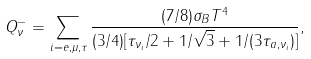<formula> <loc_0><loc_0><loc_500><loc_500>Q _ { \nu } ^ { - } = \sum _ { i = e , \mu , \tau } \frac { ( 7 / 8 ) \sigma _ { B } T ^ { 4 } } { ( 3 / 4 ) [ \tau _ { \nu _ { i } } / 2 + 1 / \sqrt { 3 } + 1 / ( 3 \tau _ { a , \nu _ { i } } ) ] } ,</formula> 